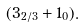Convert formula to latex. <formula><loc_0><loc_0><loc_500><loc_500>( 3 _ { 2 / 3 } + 1 _ { 0 } ) .</formula> 